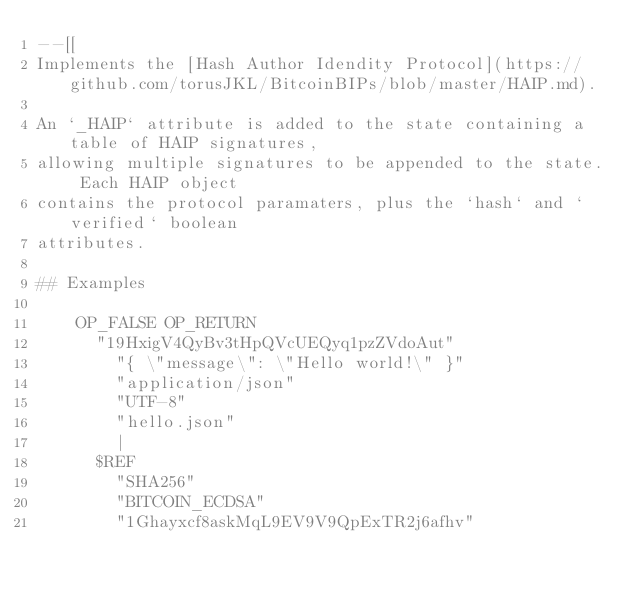<code> <loc_0><loc_0><loc_500><loc_500><_Lua_>--[[
Implements the [Hash Author Idendity Protocol](https://github.com/torusJKL/BitcoinBIPs/blob/master/HAIP.md).

An `_HAIP` attribute is added to the state containing a table of HAIP signatures,
allowing multiple signatures to be appended to the state. Each HAIP object
contains the protocol paramaters, plus the `hash` and `verified` boolean
attributes.

## Examples

    OP_FALSE OP_RETURN
      "19HxigV4QyBv3tHpQVcUEQyq1pzZVdoAut"
        "{ \"message\": \"Hello world!\" }"
        "application/json"
        "UTF-8"
        "hello.json"
        |
      $REF
        "SHA256"
        "BITCOIN_ECDSA"
        "1Ghayxcf8askMqL9EV9V9QpExTR2j6afhv"</code> 